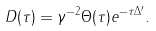Convert formula to latex. <formula><loc_0><loc_0><loc_500><loc_500>D ( \tau ) = \gamma ^ { - 2 } \Theta ( \tau ) e ^ { - \tau \Delta ^ { \prime } } .</formula> 